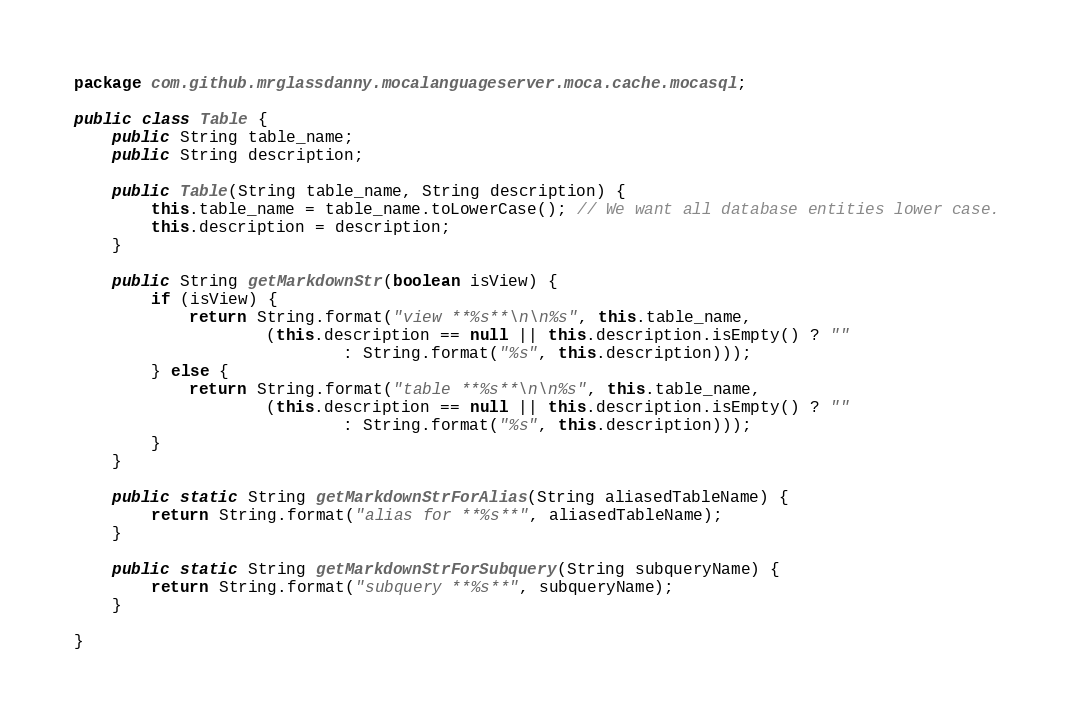Convert code to text. <code><loc_0><loc_0><loc_500><loc_500><_Java_>package com.github.mrglassdanny.mocalanguageserver.moca.cache.mocasql;

public class Table {
    public String table_name;
    public String description;

    public Table(String table_name, String description) {
        this.table_name = table_name.toLowerCase(); // We want all database entities lower case.
        this.description = description;
    }

    public String getMarkdownStr(boolean isView) {
        if (isView) {
            return String.format("view **%s**\n\n%s", this.table_name,
                    (this.description == null || this.description.isEmpty() ? ""
                            : String.format("%s", this.description)));
        } else {
            return String.format("table **%s**\n\n%s", this.table_name,
                    (this.description == null || this.description.isEmpty() ? ""
                            : String.format("%s", this.description)));
        }
    }

    public static String getMarkdownStrForAlias(String aliasedTableName) {
        return String.format("alias for **%s**", aliasedTableName);
    }

    public static String getMarkdownStrForSubquery(String subqueryName) {
        return String.format("subquery **%s**", subqueryName);
    }

}</code> 